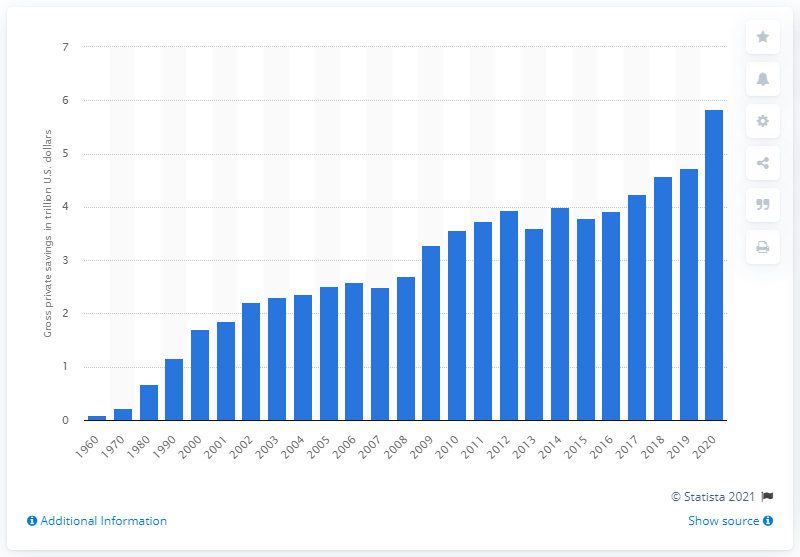Mention a couple of crucial points in this snapshot. At the end of 2020, the gross personal savings in the United States was 5.83. The increase in gross personal savings in the United States was steadily observed in the year 2015. 